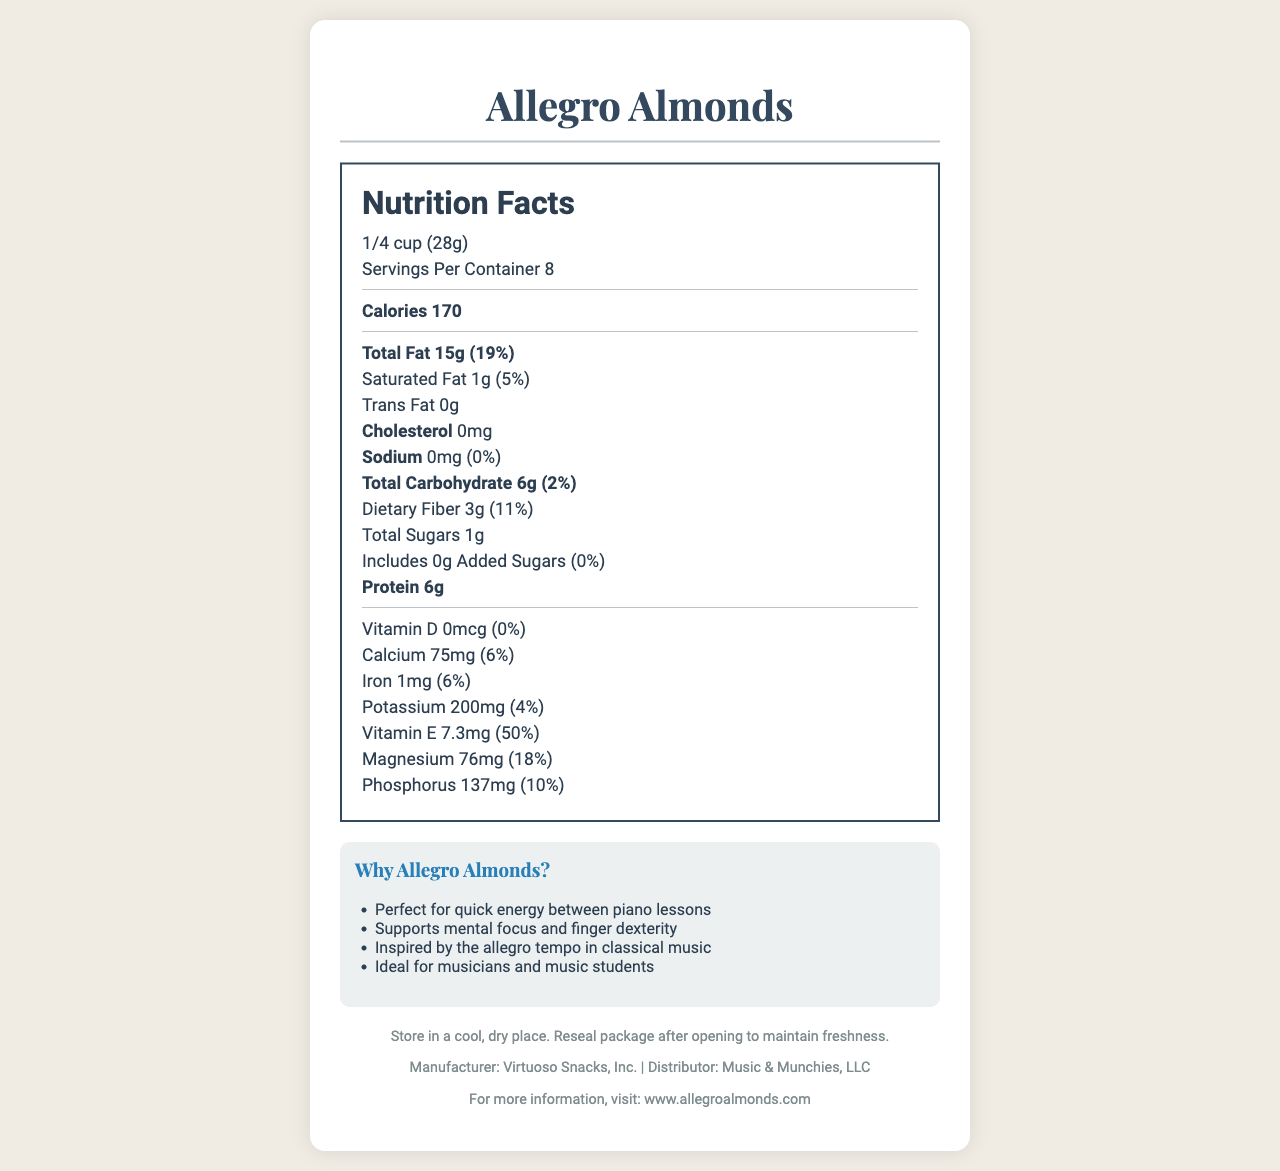what is the serving size? The document specifies that the serving size for Allegro Almonds is "1/4 cup (28g)".
Answer: 1/4 cup (28g) how many servings are in each container? The document states that there are 8 servings per container.
Answer: 8 how many calories are in one serving? Under Nutrition Facts, the document mentions that each serving has 170 calories.
Answer: 170 what is the total amount of fat in one serving? The document specifies that the total fat content per serving is 15g.
Answer: 15g what percentage of the daily value for Vitamin E is provided by one serving? The Nutrition Facts section indicates that one serving provides 50% of the daily value for Vitamin E.
Answer: 50% how much protein is in one serving? The document indicates that one serving contains 6g of protein.
Answer: 6g what is the amount of dietary fiber in a serving? The Nutrition Facts section lists dietary fiber as 3g per serving.
Answer: 3g how much potassium is in one serving? The document lists the potassium content of a serving as 200mg.
Answer: 200mg does the product contain any added sugars? The document states that added sugars are 0g.
Answer: No what is the company website for more information about Allegro Almonds? The footer of the document provides the website: www.allegroalmonds.com.
Answer: www.allegroalmonds.com What possible allergens are listed on the document? The document notes that the product contains almonds and may contain traces of other tree nuts, and is packed in a facility that processes peanuts.
Answer: Almonds, other tree nuts, peanuts What are the marketing claims mentioned in the document? A. Ideal for musicians B. Supports mental focus C. Contains peanuts D. Perfect for quick energy The document lists that Allegro Almonds are "Perfect for quick energy between piano lessons", "Supports mental focus and finger dexterity", and are "Ideal for musicians and music students".
Answer: A, B, D Which of the following is NOT mentioned as an ingredient or allergen? I. Almonds II. Other tree nuts III. Dairy IV. Peanuts The document mentions almonds, other tree nuts, and peanuts but does not mention dairy.
Answer: III. Dairy Is Allegro Almonds suitable for those avoiding cholesterol? The document specifies that the product contains 0mg of cholesterol.
Answer: Yes Summarize the main idea of the document. The document provides detailed nutritional information, suggests that the product is ideal for musicians and students, and highlights its allergen information and storage instructions.
Answer: Allegro Almonds are a nutritious snack designed for quick energy between piano lessons, containing almonds and other nutrients while being free from cholesterol and added sugars. who is the target audience for Allegro Almonds? The document suggests musicians and students but doesn't explicitly define the target audience.
Answer: Cannot be determined describe the storage instructions for Allegro Almonds. The footer section of the document provides these storage instructions for maintaining the freshness of Allegro Almonds.
Answer: Store in a cool, dry place. Reseal package after opening to maintain freshness. what is the daily value percentage for magnesium? The Nutrition Facts section specifies that the daily value percentage for magnesium per serving is 18%.
Answer: 18% 